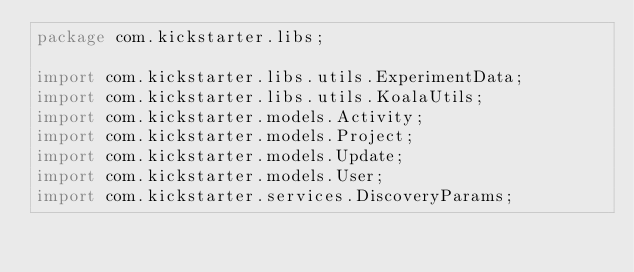<code> <loc_0><loc_0><loc_500><loc_500><_Java_>package com.kickstarter.libs;

import com.kickstarter.libs.utils.ExperimentData;
import com.kickstarter.libs.utils.KoalaUtils;
import com.kickstarter.models.Activity;
import com.kickstarter.models.Project;
import com.kickstarter.models.Update;
import com.kickstarter.models.User;
import com.kickstarter.services.DiscoveryParams;</code> 